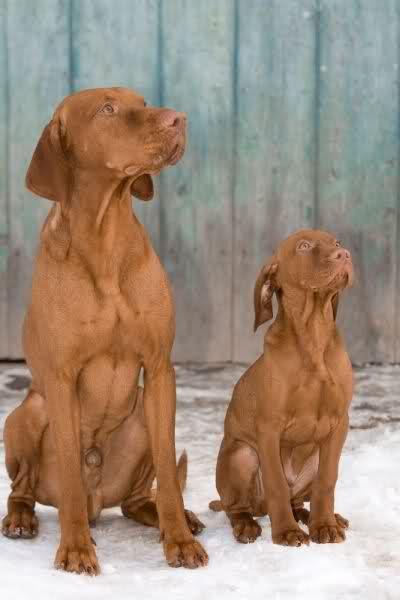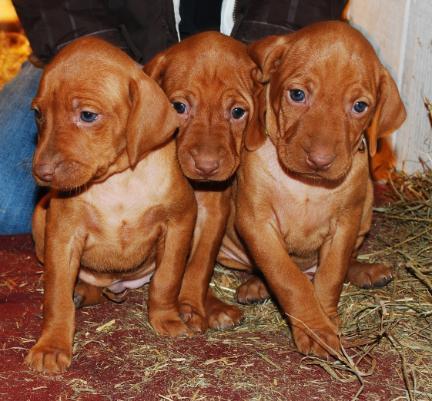The first image is the image on the left, the second image is the image on the right. Assess this claim about the two images: "There are three dog in a row with different color collars on.". Correct or not? Answer yes or no. No. The first image is the image on the left, the second image is the image on the right. Examine the images to the left and right. Is the description "There are more dogs in the image on the right." accurate? Answer yes or no. Yes. 